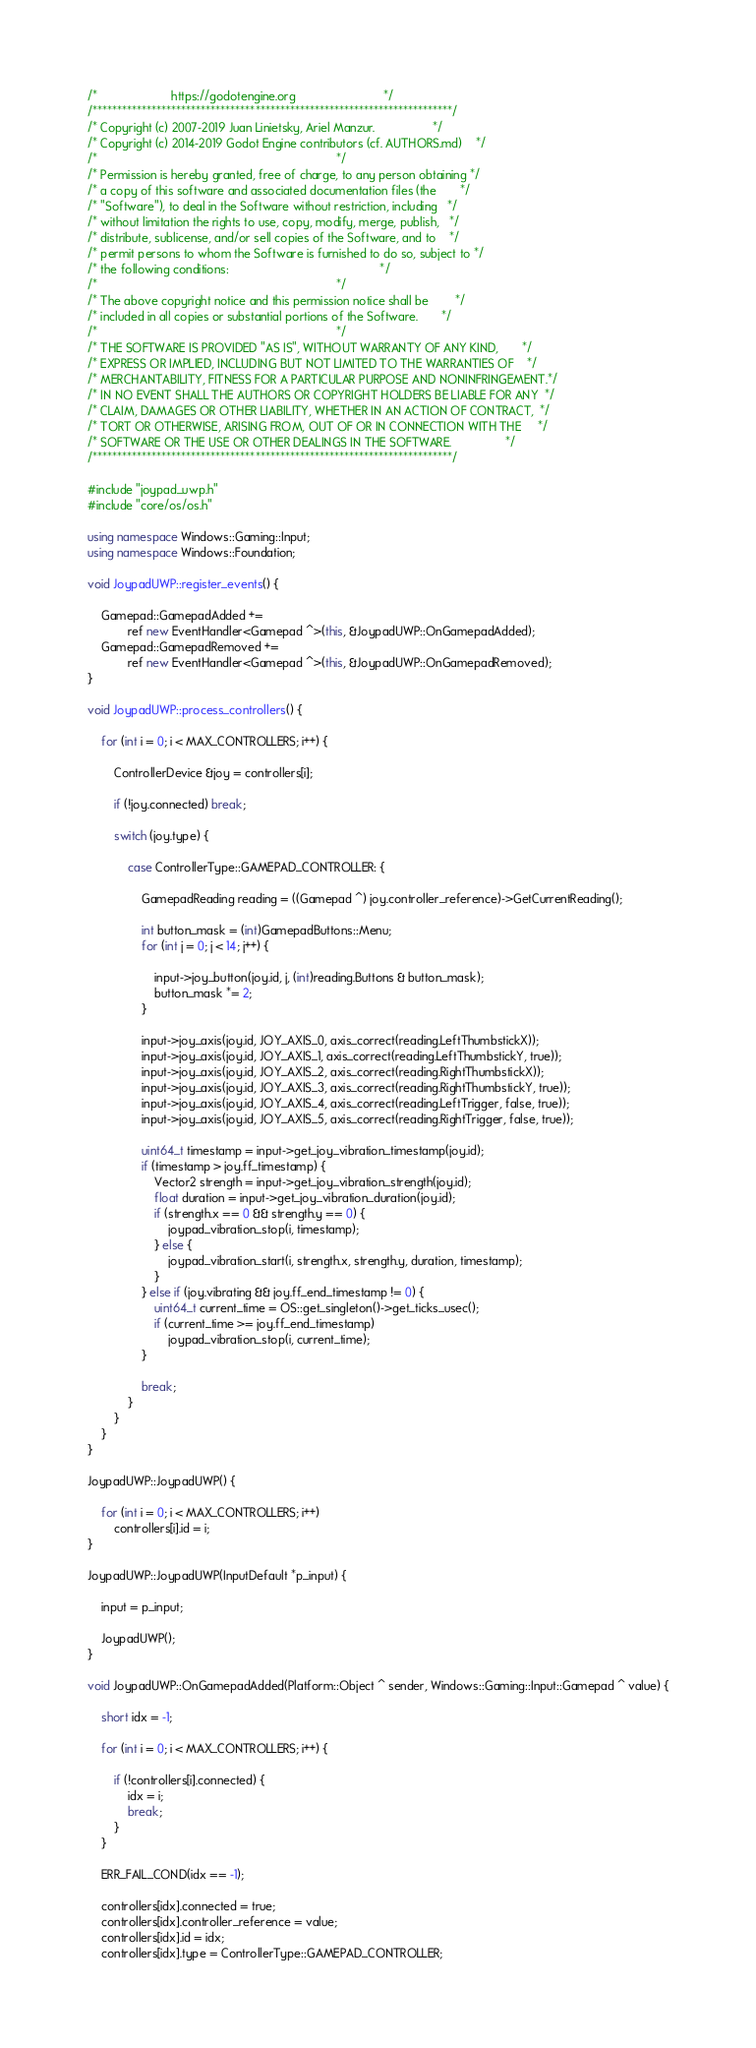<code> <loc_0><loc_0><loc_500><loc_500><_C++_>/*                      https://godotengine.org                          */
/*************************************************************************/
/* Copyright (c) 2007-2019 Juan Linietsky, Ariel Manzur.                 */
/* Copyright (c) 2014-2019 Godot Engine contributors (cf. AUTHORS.md)    */
/*                                                                       */
/* Permission is hereby granted, free of charge, to any person obtaining */
/* a copy of this software and associated documentation files (the       */
/* "Software"), to deal in the Software without restriction, including   */
/* without limitation the rights to use, copy, modify, merge, publish,   */
/* distribute, sublicense, and/or sell copies of the Software, and to    */
/* permit persons to whom the Software is furnished to do so, subject to */
/* the following conditions:                                             */
/*                                                                       */
/* The above copyright notice and this permission notice shall be        */
/* included in all copies or substantial portions of the Software.       */
/*                                                                       */
/* THE SOFTWARE IS PROVIDED "AS IS", WITHOUT WARRANTY OF ANY KIND,       */
/* EXPRESS OR IMPLIED, INCLUDING BUT NOT LIMITED TO THE WARRANTIES OF    */
/* MERCHANTABILITY, FITNESS FOR A PARTICULAR PURPOSE AND NONINFRINGEMENT.*/
/* IN NO EVENT SHALL THE AUTHORS OR COPYRIGHT HOLDERS BE LIABLE FOR ANY  */
/* CLAIM, DAMAGES OR OTHER LIABILITY, WHETHER IN AN ACTION OF CONTRACT,  */
/* TORT OR OTHERWISE, ARISING FROM, OUT OF OR IN CONNECTION WITH THE     */
/* SOFTWARE OR THE USE OR OTHER DEALINGS IN THE SOFTWARE.                */
/*************************************************************************/

#include "joypad_uwp.h"
#include "core/os/os.h"

using namespace Windows::Gaming::Input;
using namespace Windows::Foundation;

void JoypadUWP::register_events() {

	Gamepad::GamepadAdded +=
			ref new EventHandler<Gamepad ^>(this, &JoypadUWP::OnGamepadAdded);
	Gamepad::GamepadRemoved +=
			ref new EventHandler<Gamepad ^>(this, &JoypadUWP::OnGamepadRemoved);
}

void JoypadUWP::process_controllers() {

	for (int i = 0; i < MAX_CONTROLLERS; i++) {

		ControllerDevice &joy = controllers[i];

		if (!joy.connected) break;

		switch (joy.type) {

			case ControllerType::GAMEPAD_CONTROLLER: {

				GamepadReading reading = ((Gamepad ^) joy.controller_reference)->GetCurrentReading();

				int button_mask = (int)GamepadButtons::Menu;
				for (int j = 0; j < 14; j++) {

					input->joy_button(joy.id, j, (int)reading.Buttons & button_mask);
					button_mask *= 2;
				}

				input->joy_axis(joy.id, JOY_AXIS_0, axis_correct(reading.LeftThumbstickX));
				input->joy_axis(joy.id, JOY_AXIS_1, axis_correct(reading.LeftThumbstickY, true));
				input->joy_axis(joy.id, JOY_AXIS_2, axis_correct(reading.RightThumbstickX));
				input->joy_axis(joy.id, JOY_AXIS_3, axis_correct(reading.RightThumbstickY, true));
				input->joy_axis(joy.id, JOY_AXIS_4, axis_correct(reading.LeftTrigger, false, true));
				input->joy_axis(joy.id, JOY_AXIS_5, axis_correct(reading.RightTrigger, false, true));

				uint64_t timestamp = input->get_joy_vibration_timestamp(joy.id);
				if (timestamp > joy.ff_timestamp) {
					Vector2 strength = input->get_joy_vibration_strength(joy.id);
					float duration = input->get_joy_vibration_duration(joy.id);
					if (strength.x == 0 && strength.y == 0) {
						joypad_vibration_stop(i, timestamp);
					} else {
						joypad_vibration_start(i, strength.x, strength.y, duration, timestamp);
					}
				} else if (joy.vibrating && joy.ff_end_timestamp != 0) {
					uint64_t current_time = OS::get_singleton()->get_ticks_usec();
					if (current_time >= joy.ff_end_timestamp)
						joypad_vibration_stop(i, current_time);
				}

				break;
			}
		}
	}
}

JoypadUWP::JoypadUWP() {

	for (int i = 0; i < MAX_CONTROLLERS; i++)
		controllers[i].id = i;
}

JoypadUWP::JoypadUWP(InputDefault *p_input) {

	input = p_input;

	JoypadUWP();
}

void JoypadUWP::OnGamepadAdded(Platform::Object ^ sender, Windows::Gaming::Input::Gamepad ^ value) {

	short idx = -1;

	for (int i = 0; i < MAX_CONTROLLERS; i++) {

		if (!controllers[i].connected) {
			idx = i;
			break;
		}
	}

	ERR_FAIL_COND(idx == -1);

	controllers[idx].connected = true;
	controllers[idx].controller_reference = value;
	controllers[idx].id = idx;
	controllers[idx].type = ControllerType::GAMEPAD_CONTROLLER;
</code> 